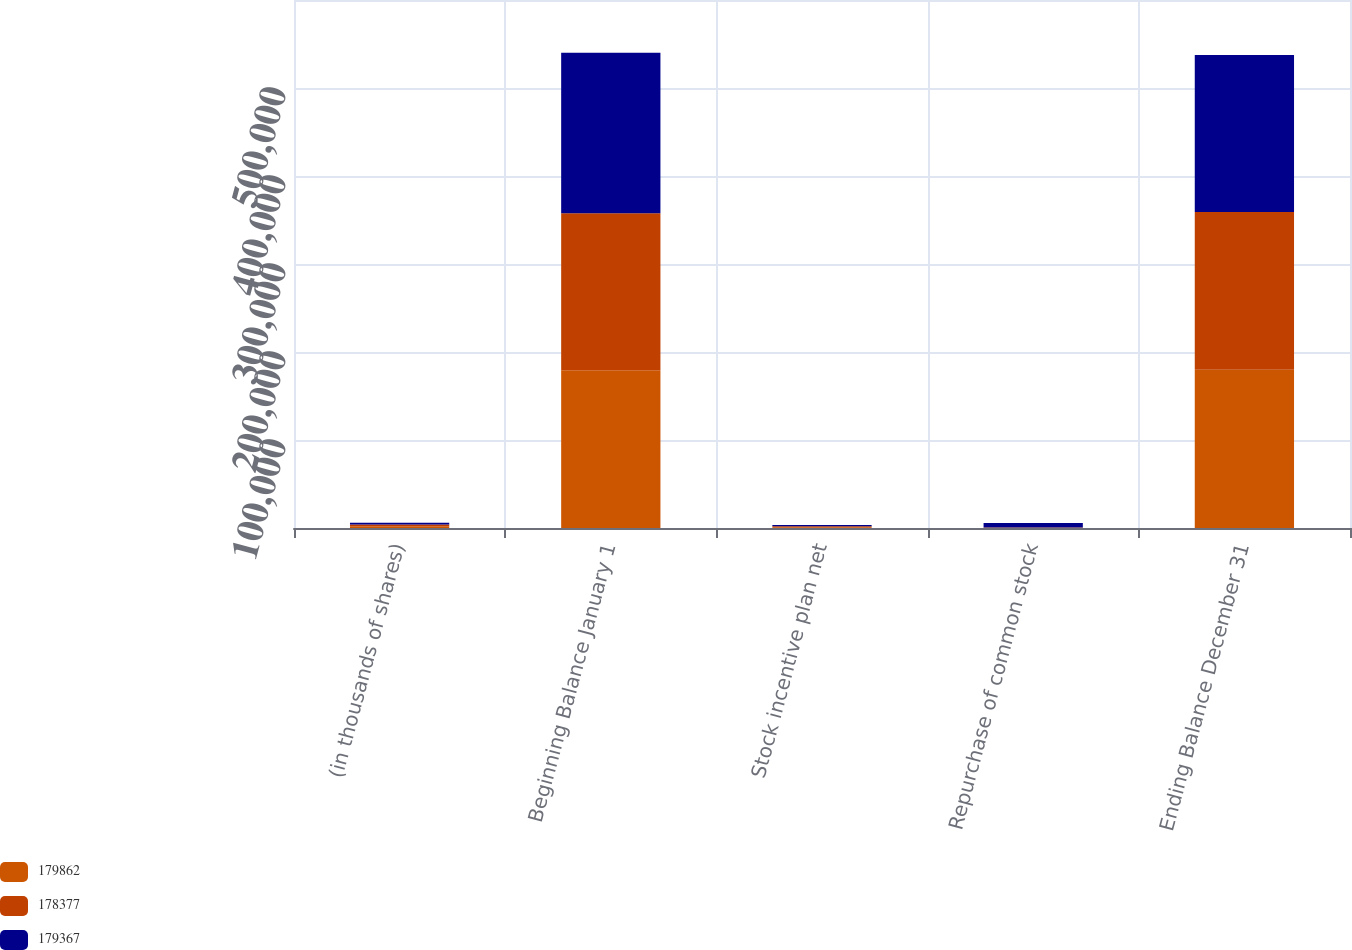<chart> <loc_0><loc_0><loc_500><loc_500><stacked_bar_chart><ecel><fcel>(in thousands of shares)<fcel>Beginning Balance January 1<fcel>Stock incentive plan net<fcel>Repurchase of common stock<fcel>Ending Balance December 31<nl><fcel>179862<fcel>2017<fcel>179367<fcel>985<fcel>490<fcel>179862<nl><fcel>178377<fcel>2016<fcel>178377<fcel>1085<fcel>95<fcel>179367<nl><fcel>179367<fcel>2015<fcel>182300<fcel>1280<fcel>5203<fcel>178377<nl></chart> 